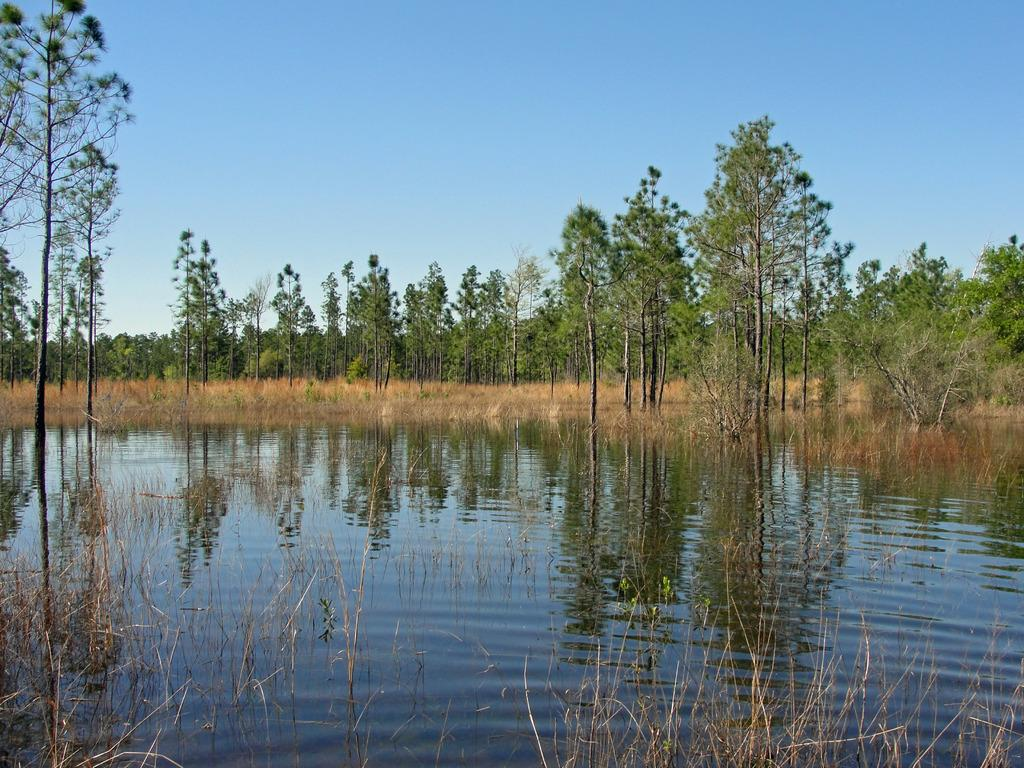What is the main element present in the image? There is water in the image. How is the water distributed in the image? The water is present all over the front of the image. What type of vegetation can be seen on the ground in the image? There is grass and plants on the ground in the image. What other natural elements are present in the image? Trees are present in the image. Can you tell me how many kittens are participating in the competition in the image? There are no kittens or competitions present in the image; it features water, grass, plants, and trees. What type of ornament is hanging from the tree in the image? There is no ornament present in the image; it only features water, grass, plants, and trees. 